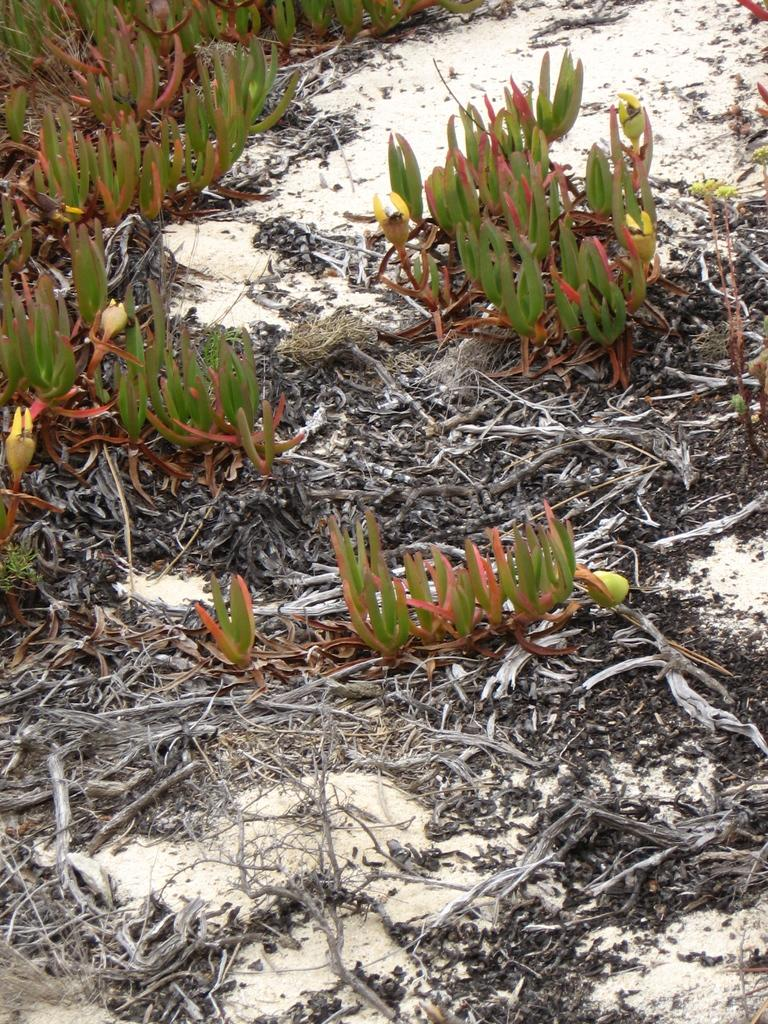What can be seen on the land in the image? There are dry stems on the land in the image. What might the dry stems be from? The dry stems may be from plants. How many houses can be seen in the image? There are no houses present in the image; it only features dry stems on the land. What type of control system is being used by the pig in the image? There is no pig present in the image, and therefore no control system can be observed. 